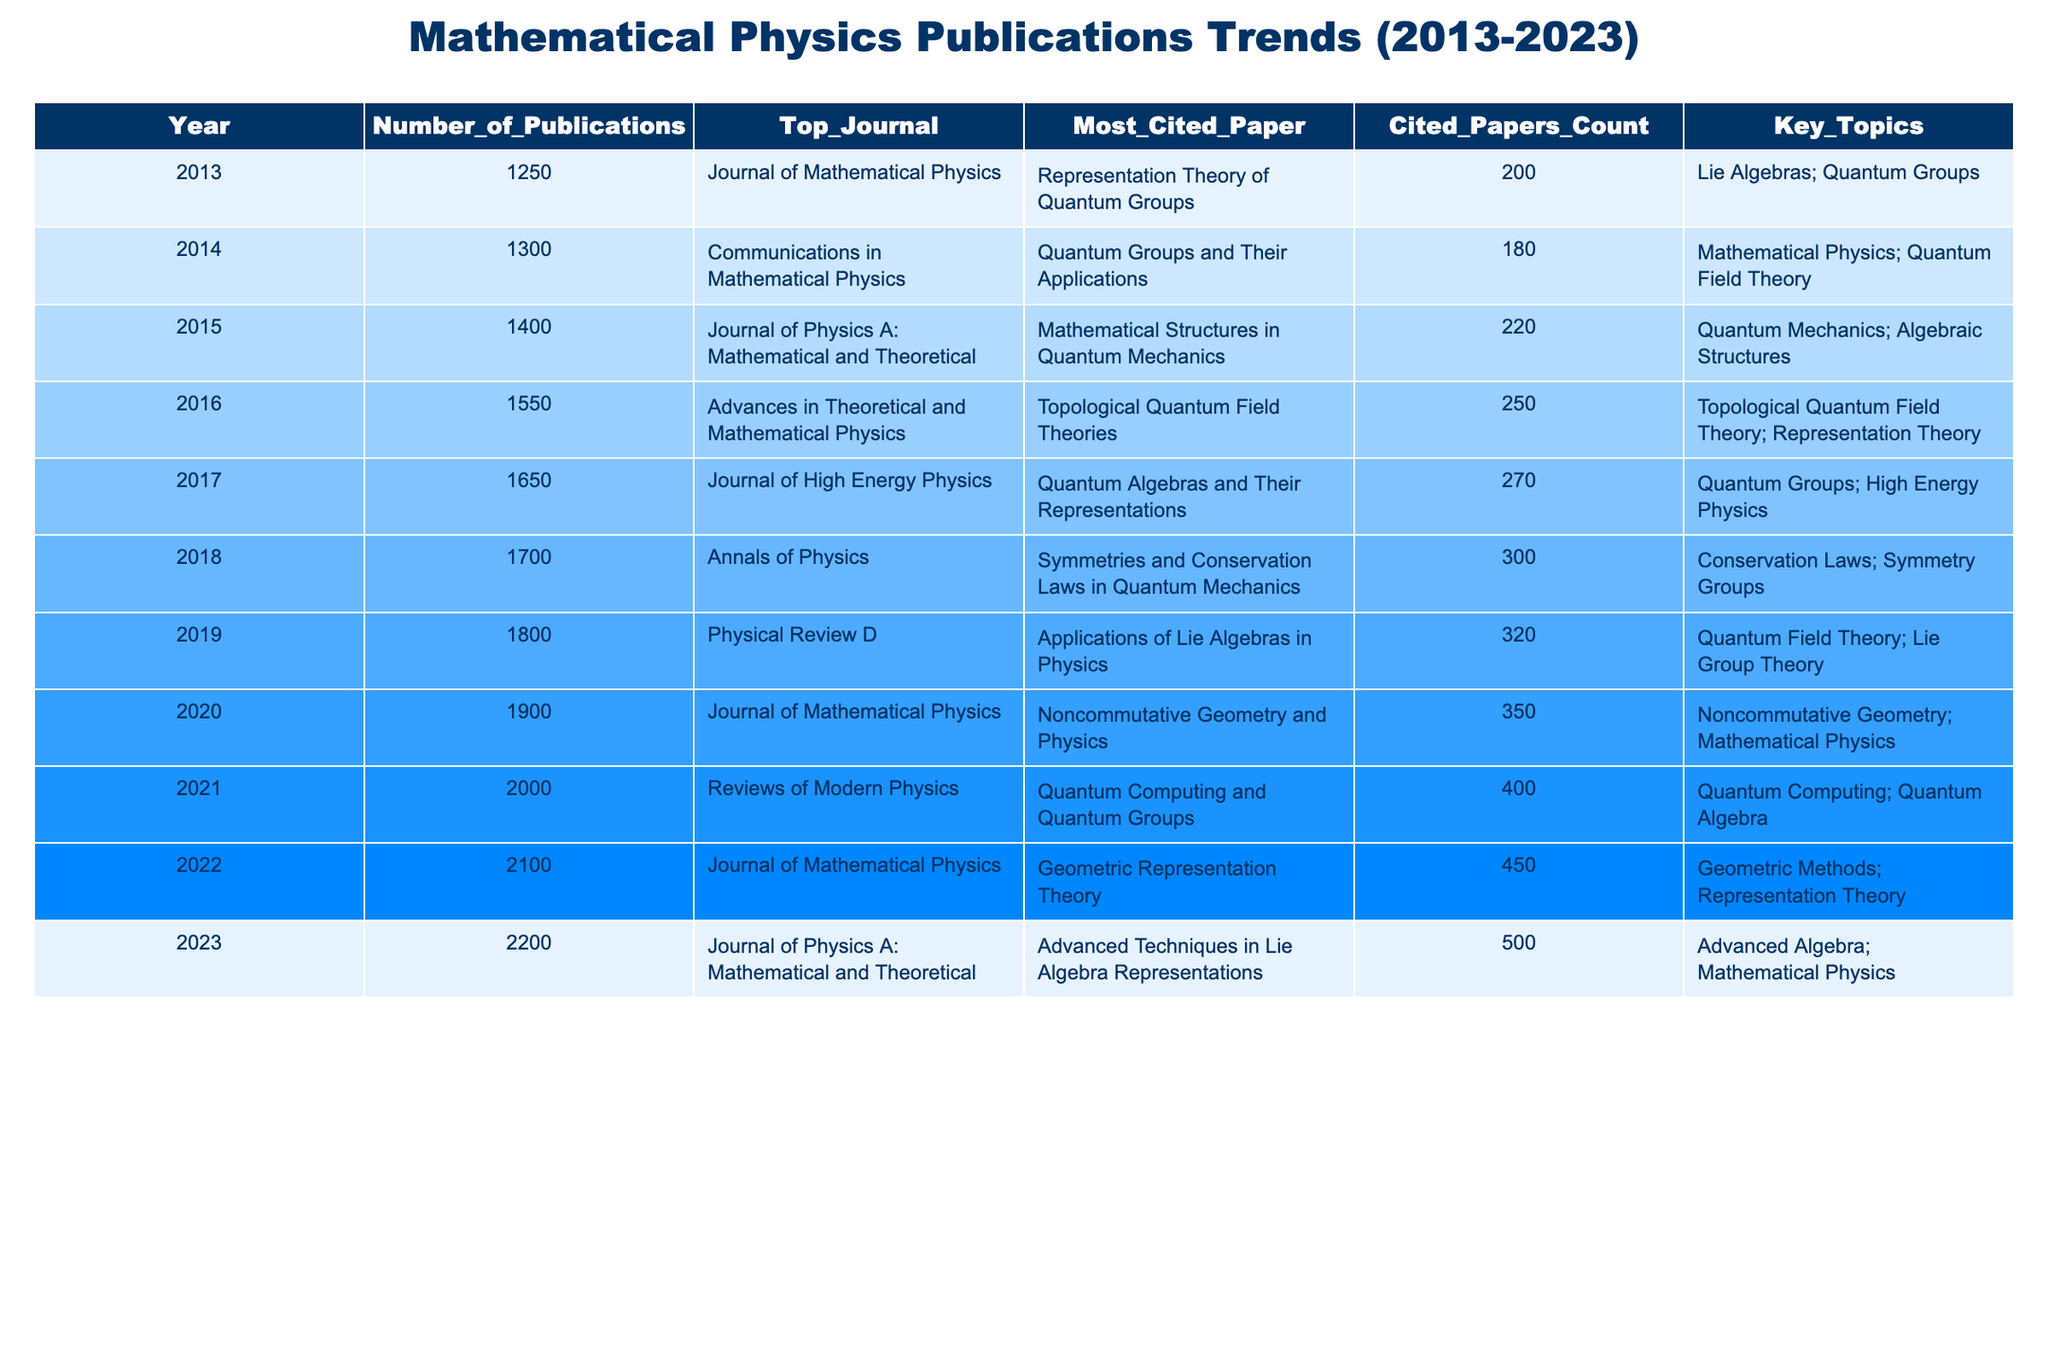What was the number of publications in 2016? The table shows that the number of publications for the year 2016 is clearly listed as 1550.
Answer: 1550 Which journal had the most publications in 2021? According to the table, the journal with the most publications in 2021 is "Reviews of Modern Physics."
Answer: Reviews of Modern Physics How many publications were recorded in the years 2015 and 2016 combined? From the table, the number of publications in 2015 is 1400 and in 2016 is 1550; adding these gives 1400 + 1550 = 2950.
Answer: 2950 What is the trend in the number of publications from 2013 to 2023? The table indicates a steady increase in the number of publications each year from 1250 in 2013 to 2200 in 2023, suggesting a positive trend.
Answer: Positive trend Is the most cited paper in 2014 more cited than the most cited paper in 2013? The table lists the most cited paper in 2014 as having 180 citations, while the paper from 2013 has 200 citations, so the paper from 2014 is less cited.
Answer: No What was the year with the highest count of cited papers, and how many cited papers were there? The highest count of cited papers is in 2023, with a total of 500 cited papers listed in the table.
Answer: 2023, 500 Calculate the average number of publications from 2013 to 2023. The total publications from 2013 to 2023 can be summed as 1250 + 1300 + 1400 + 1550 + 1650 + 1700 + 1800 + 1900 + 2000 + 2100 + 2200 =  20500. Since there are 11 years, the average is 20500 / 11 ≈ 1863.64.
Answer: Approximately 1863.64 Which key topic had the most focus in 2022 based on number of publications? The table highlights that the key topic in 2022 was "Geometric Methods; Representation Theory", indicating that there was significant focus in that area.
Answer: Geometric Methods; Representation Theory Has the journal "Journal of Mathematical Physics" been the most productive throughout the decade? While "Journal of Mathematical Physics" appears multiple times, it is not the journal with the highest number of publications every year; hence, it has not consistently been the most productive.
Answer: No In which year did the number of publications exceed 2000 for the first time? By examining the table, it is clear that the number of publications exceeded 2000 for the first time in 2021, as it was listed at 2000 that year.
Answer: 2021 What were the most cited papers in 2018 and 2019, and how many citations did they receive? In 2018, the most cited paper was "Symmetries and Conservation Laws in Quantum Mechanics" with 300 citations, and in 2019 it was "Applications of Lie Algebras in Physics" with 320 citations.
Answer: 300 in 2018, 320 in 2019 